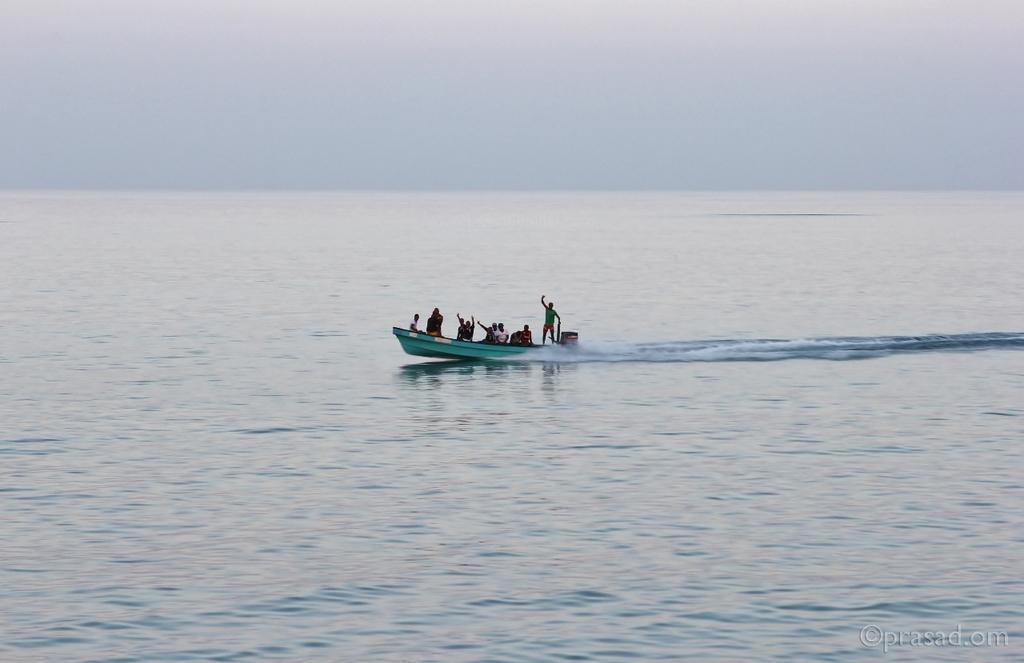Please provide a concise description of this image. As we can see in the image there are few people on boat, water and sky. 